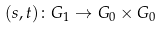<formula> <loc_0><loc_0><loc_500><loc_500>( s , t ) \colon G _ { 1 } \to G _ { 0 } \times G _ { 0 }</formula> 